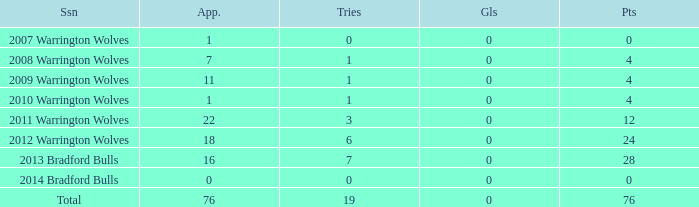What is the sum of appearance when goals is more than 0? None. 